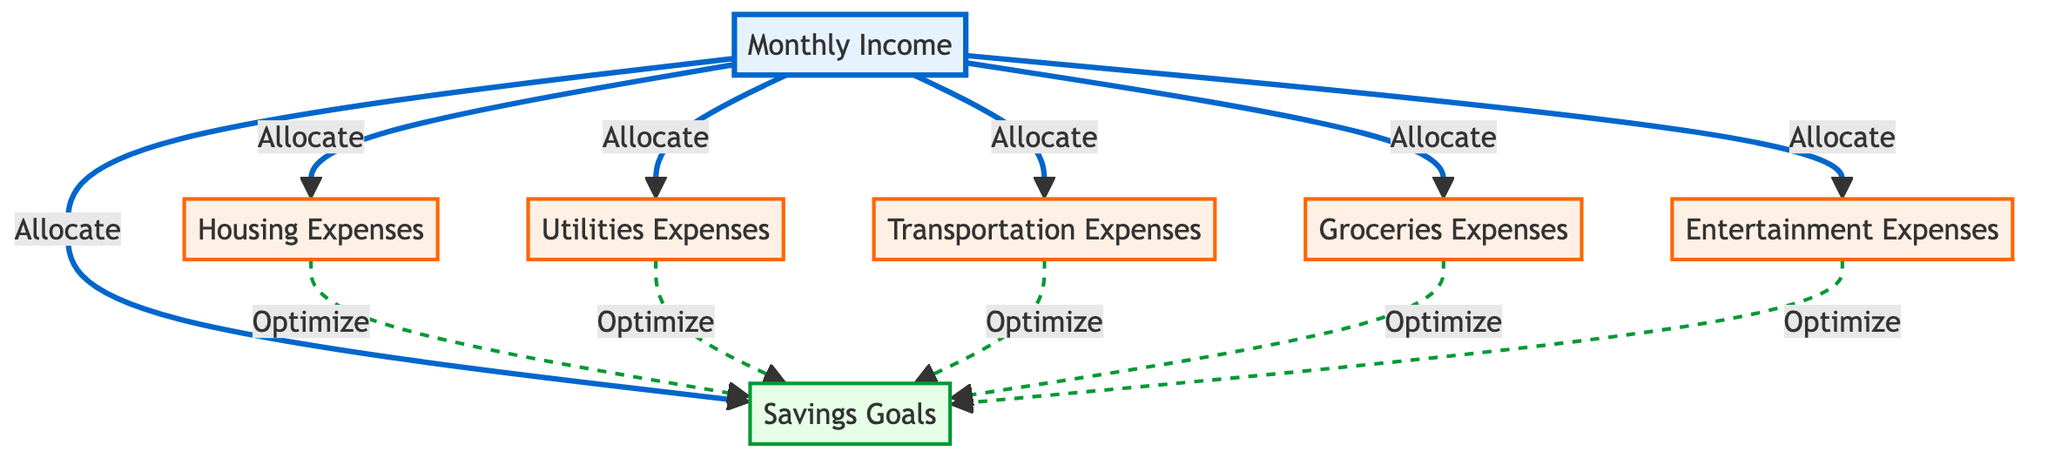What is the total number of nodes in the diagram? The diagram contains a list of nodes that represent different financial categories. By counting them, we find there are seven distinct nodes: Monthly Income, Housing Expenses, Utilities Expenses, Transportation Expenses, Groceries Expenses, Entertainment Expenses, and Savings Goals.
Answer: 7 What type of relationship exists between "Income" and "Savings"? The connection from "Income" to "Savings" shows a direct allocation. This indicates that a portion of the monthly income is set aside for savings, which is a critical aspect of budget allocation.
Answer: Allocate How many expenses are linked to "Income"? By examining the edges that originate from the "Income" node, we see that five expenses are directly allocated from monthly income: Housing, Utilities, Transportation, Groceries, and Entertainment.
Answer: 5 Which node represents the expense for food? Looking at the list of expenses, "Groceries" is specifically associated with food-related costs, highlighting its importance in everyday spending.
Answer: Groceries Expenses How does "Transportation" affect "Savings"? The edge going from "Transportation" to "Savings" signifies that managing transportation expenses effectively can lead toward better savings. This implies that if transportation expenses are optimized, it may increase savings.
Answer: Optimize Which node has the most incoming edges? The "Savings" node receives connections from multiple expense nodes as well as directly from "Income." This means that it aggregates influence from all other financial aspects in this diagram, indicating its significance in the budget.
Answer: Savings Goals What is the total number of edges in the diagram? By counting the lines connecting the nodes, we find that there are 11 edges in total, signifying the relationships between the monthly income and various expenses, along with their influence on savings.
Answer: 11 What color represents the "Savings" goals? The node for "Savings Goals" is depicted in a light green shade according to the defined classes in the diagram, which visually distinguishes it from the other nodes representing expenses and income.
Answer: Light green What is the relationship between "Utilities" and "Savings"? The connection from "Utilities" to "Savings" indicates that effectively managing utilities expenses can optimize savings, suggesting a beneficial cycle in budget planning.
Answer: Optimize Which node directly connects to all other expense nodes? The "Income" node connects directly to all other expense nodes in the graph, showcasing its role as the primary source of funding for various financial obligations.
Answer: Monthly Income 